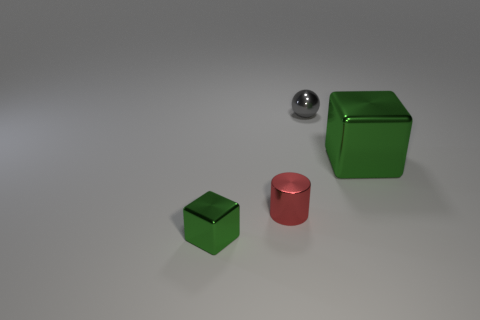Add 2 small red cylinders. How many objects exist? 6 Subtract all cylinders. How many objects are left? 3 Add 4 brown blocks. How many brown blocks exist? 4 Subtract 0 yellow cylinders. How many objects are left? 4 Subtract all shiny spheres. Subtract all tiny red metal things. How many objects are left? 2 Add 4 green shiny things. How many green shiny things are left? 6 